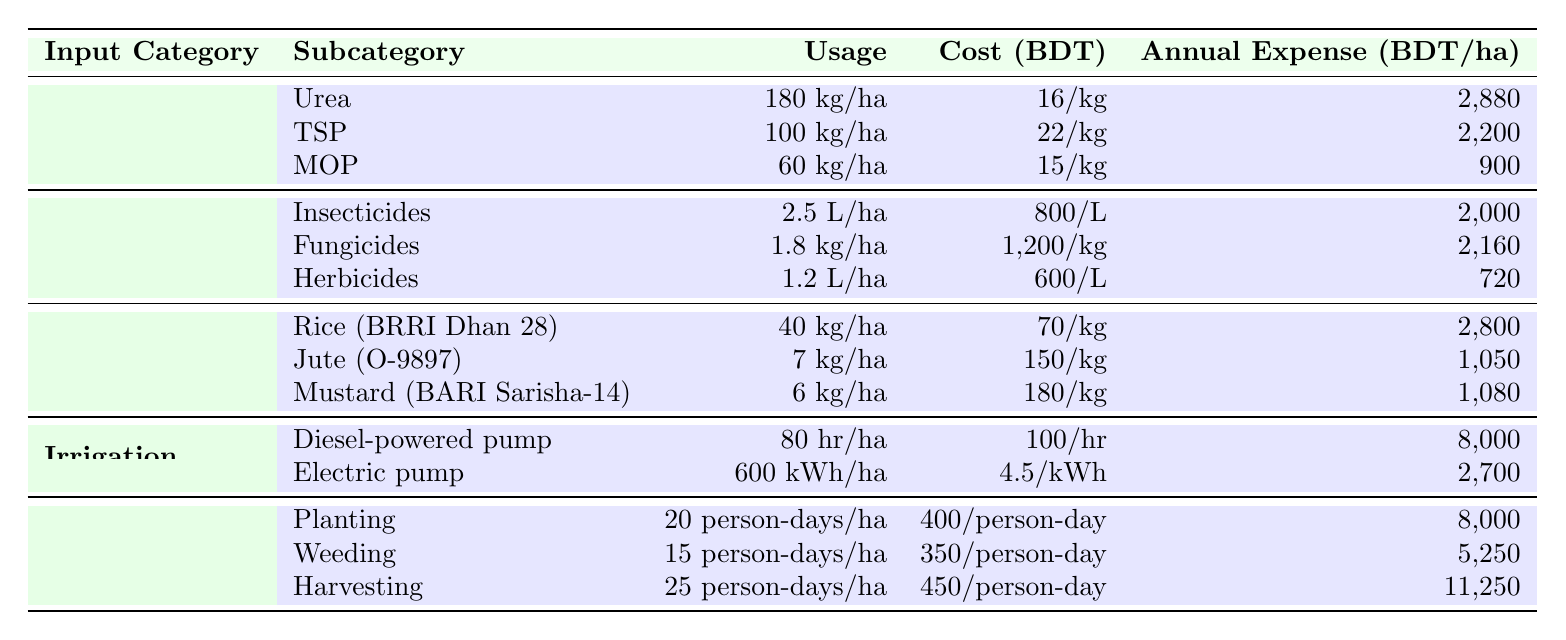What is the annual expense for Urea per hectare? The table indicates that the annual expense for Urea is listed under the Fertilizers category, specifically as 2880 BDT/hectare.
Answer: 2880 BDT/hectare Which pesticide has the highest annual expense? By examining the Pesticides section, Fungicides have the highest annual expense of 2160 BDT/hectare, compared to Insecticides (2000 BDT/hectare) and Herbicides (720 BDT/hectare).
Answer: Fungicides What is the total annual expense for all fertilizers combined? The annual expenses for fertilizers are: Urea (2880 BDT), TSP (2200 BDT), and MOP (900 BDT). Adding them gives 2880 + 2200 + 900 = 5980 BDT.
Answer: 5980 BDT Is the cost of Herbicides more than the cost of Muriate of Potash? The cost of Herbicides is 600 BDT/L, while Muriate of Potash costs 15 BDT/kg. Since they are different units, we can't directly compare them, but generally, Herbicides are considered more expensive.
Answer: Yes What percentage of the total annual expense for pesticides is spent on Insecticides? The total annual expenses for pesticides are Insecticides (2000 BDT) + Fungicides (2160 BDT) + Herbicides (720 BDT) = 4880 BDT. The percentage spent on Insecticides is (2000/4880)*100 ≈ 40.98%.
Answer: Approximately 41% How does the annual expense for Harvesting compare to that of Weeding? The annual expense for Harvesting is 11250 BDT/hectare, while for Weeding it is 5250 BDT/hectare. The difference is 11250 - 5250 = 6000 BDT, indicating that Harvesting costs significantly more.
Answer: Harvesting costs 6000 BDT more What is the most cost-effective irrigation method based on annual expense? The annual expenses for irrigation methods are Diesel-powered pump (8000 BDT) and Electric pump (2700 BDT). The Electric pump has the lower expense, making it the more cost-effective option.
Answer: Electric pump If a farmer uses all inputs, what would be their total annual expenses per hectare? Adding all annual expenses: Fertilizers (5980 BDT) + Pesticides (4880 BDT) + Seeds (2800 + 1050 + 1080 = 4930 BDT) + Irrigation (8000 + 2700 = 10700 BDT) + Labor (8000 + 5250 + 11250 = 24400 BDT). Thus, total = 5980 + 4880 + 4930 + 10700 + 24400 = 50890 BDT.
Answer: 50890 BDT Which seed has the highest cost per kg? Among the seeds, Mustard (BARI Sarisha-14) has the highest cost at 180 BDT/kg, compared to Rice (70 BDT/kg) and Jute (150 BDT/kg).
Answer: Mustard (BARI Sarisha-14) If a farmer wants to grow 2 hectares of Rice (BRRI Dhan 28), what would be the total cost for seeds? The cost for Rice is 70 BDT/kg, and for 40 kg/hectare, the total for 2 hectares is 40 kg * 2 * 70 BDT = 5600 BDT.
Answer: 5600 BDT 